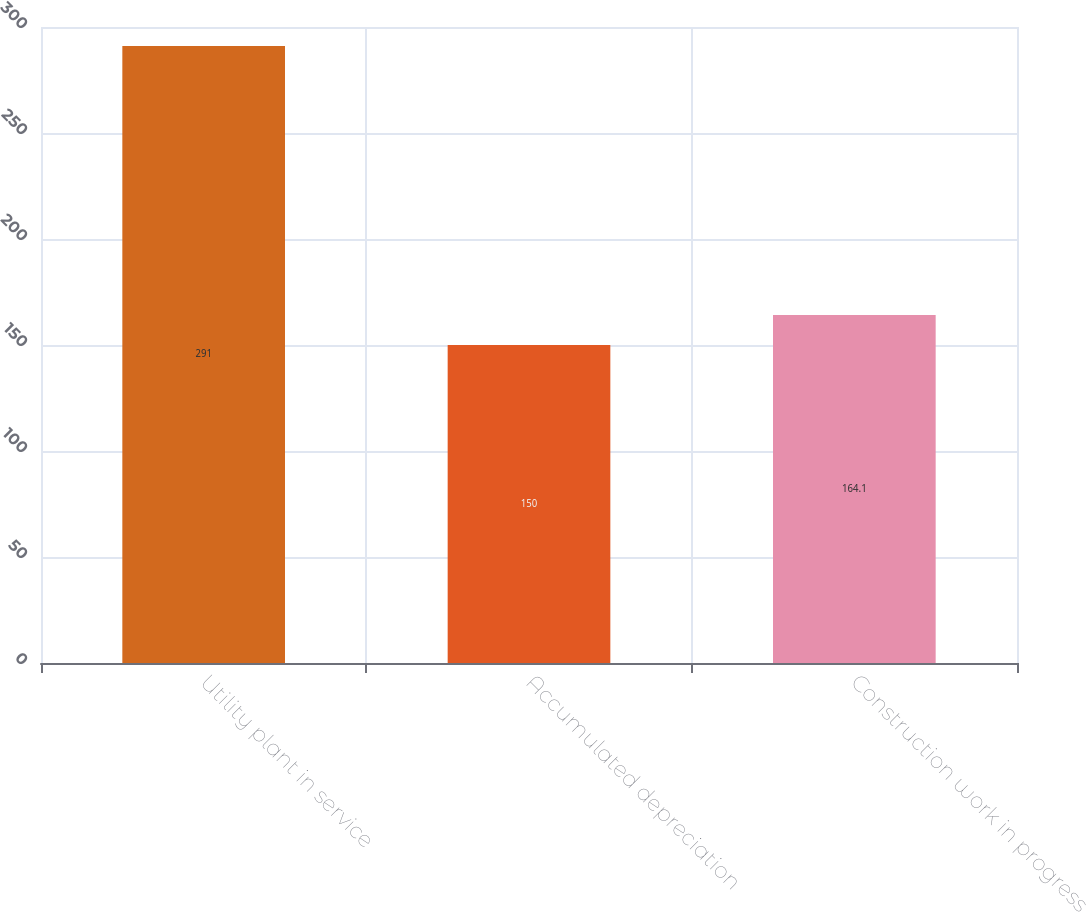Convert chart. <chart><loc_0><loc_0><loc_500><loc_500><bar_chart><fcel>Utility plant in service<fcel>Accumulated depreciation<fcel>Construction work in progress<nl><fcel>291<fcel>150<fcel>164.1<nl></chart> 